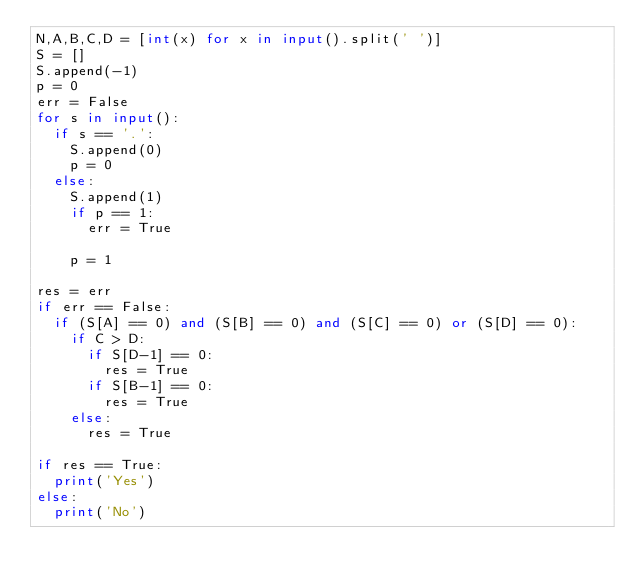<code> <loc_0><loc_0><loc_500><loc_500><_Python_>N,A,B,C,D = [int(x) for x in input().split(' ')]
S = []
S.append(-1)
p = 0
err = False
for s in input():
  if s == '.':
    S.append(0)
    p = 0
  else:
    S.append(1)
    if p == 1:
      err = True
    
    p = 1
    
res = err
if err == False:
  if (S[A] == 0) and (S[B] == 0) and (S[C] == 0) or (S[D] == 0):
    if C > D:
      if S[D-1] == 0:
        res = True
      if S[B-1] == 0:
        res = True
    else:
      res = True
    
if res == True:
  print('Yes')
else:
  print('No')</code> 